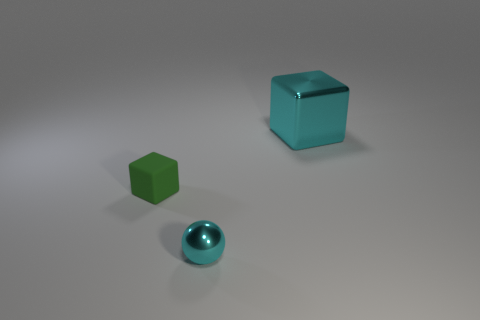Add 3 cyan shiny blocks. How many objects exist? 6 Subtract all green cubes. How many cubes are left? 1 Subtract all blocks. How many objects are left? 1 Subtract 1 balls. How many balls are left? 0 Add 2 small cyan balls. How many small cyan balls are left? 3 Add 1 large metal blocks. How many large metal blocks exist? 2 Subtract 0 purple cubes. How many objects are left? 3 Subtract all brown blocks. Subtract all purple cylinders. How many blocks are left? 2 Subtract all big shiny things. Subtract all cyan spheres. How many objects are left? 1 